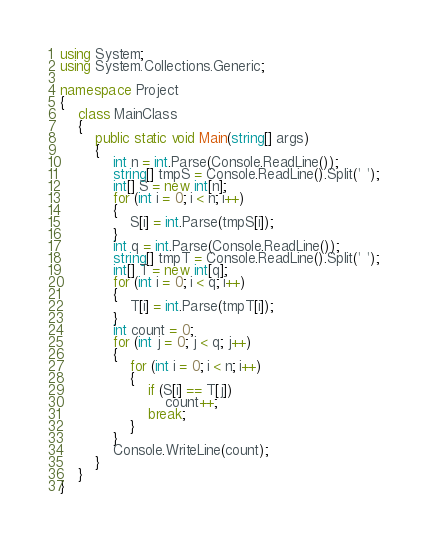<code> <loc_0><loc_0><loc_500><loc_500><_C#_>using System;
using System.Collections.Generic;

namespace Project
{
	class MainClass
	{
		public static void Main(string[] args)
		{
			int n = int.Parse(Console.ReadLine());
			string[] tmpS = Console.ReadLine().Split(' ');
			int[] S = new int[n];
			for (int i = 0; i < n; i++)
			{
				S[i] = int.Parse(tmpS[i]);
			}
			int q = int.Parse(Console.ReadLine());
			string[] tmpT = Console.ReadLine().Split(' ');
			int[] T = new int[q];
			for (int i = 0; i < q; i++)
			{
				T[i] = int.Parse(tmpT[i]);
			}
			int count = 0;
			for (int j = 0; j < q; j++)
			{
				for (int i = 0; i < n; i++)
				{
					if (S[i] == T[j])
						count++;
					break;
				}
			}
			Console.WriteLine(count);
		}
	}
}</code> 